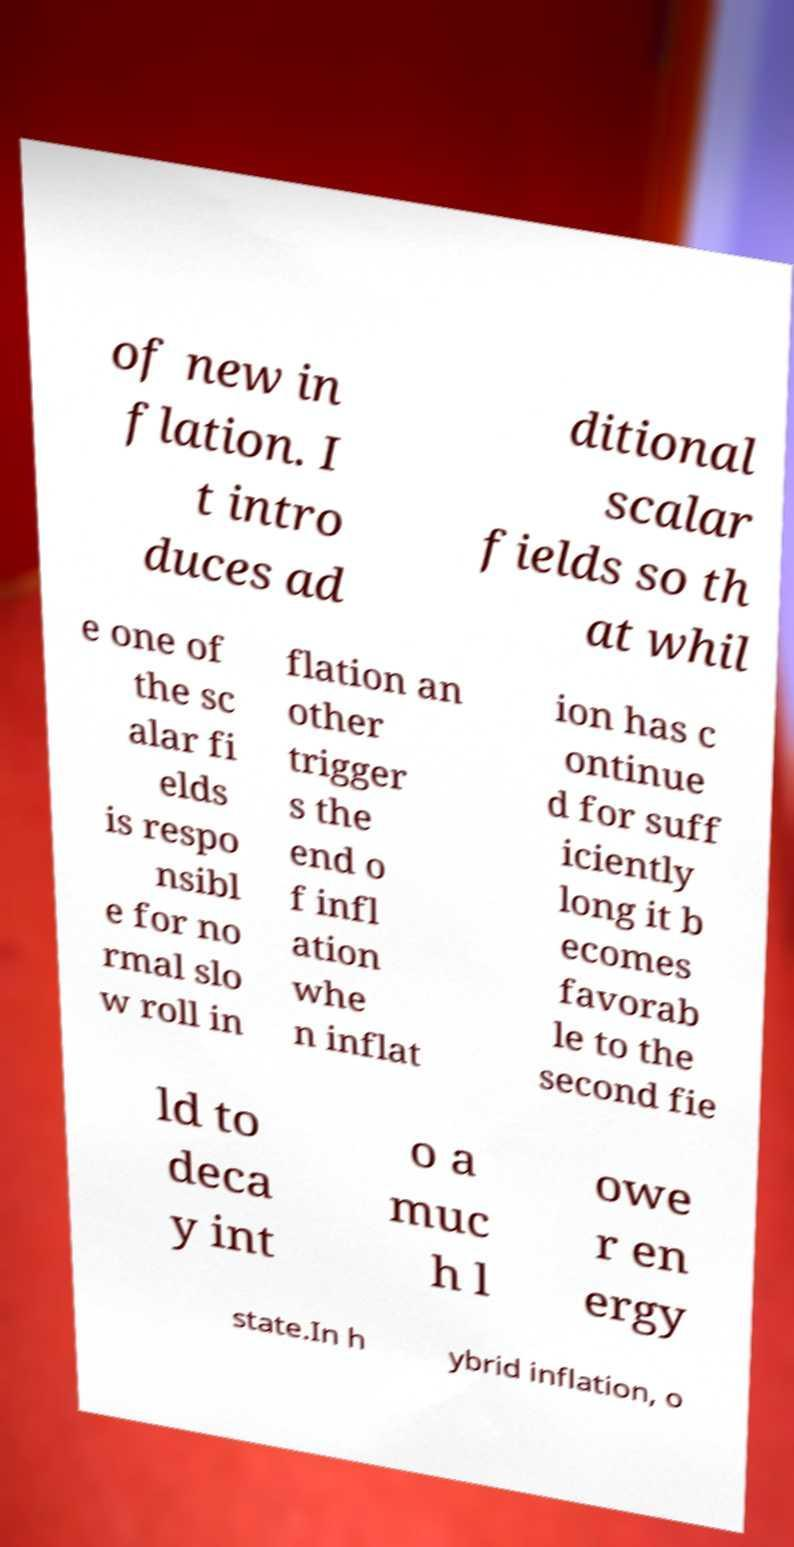Can you accurately transcribe the text from the provided image for me? of new in flation. I t intro duces ad ditional scalar fields so th at whil e one of the sc alar fi elds is respo nsibl e for no rmal slo w roll in flation an other trigger s the end o f infl ation whe n inflat ion has c ontinue d for suff iciently long it b ecomes favorab le to the second fie ld to deca y int o a muc h l owe r en ergy state.In h ybrid inflation, o 